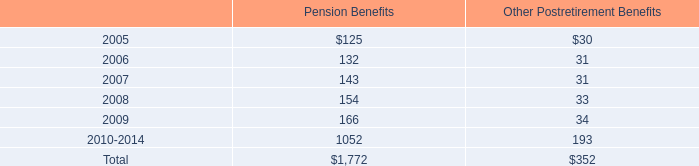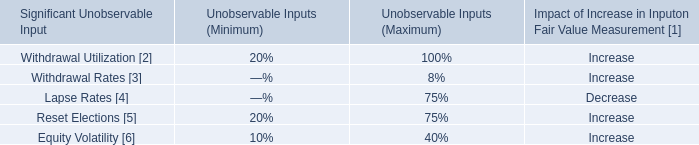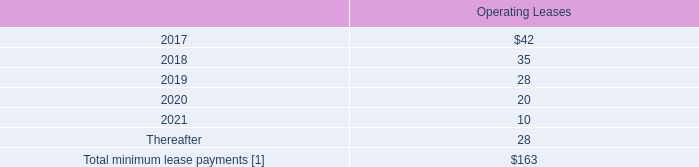what was the average shares the company granted of common stock from 2002 to 2004 
Computations: ((40852 + (315452 + 333712)) / 3)
Answer: 230005.33333. 